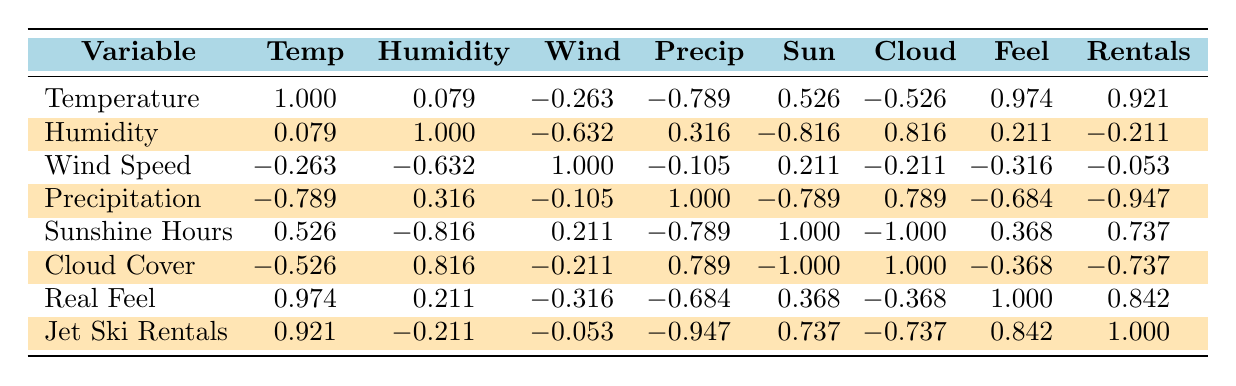What is the correlation between average temperature and jet ski rentals? The correlation value between average temperature and jet ski rentals is 0.921, which indicates a strong positive correlation. This suggests that as the average temperature increases, the demand for jet ski rentals also tends to increase.
Answer: 0.921 Did humidity levels have a negative correlation with jet ski rentals? The correlation value for humidity and jet ski rentals is -0.211, which indicates a weak negative correlation. This means that higher humidity levels are slightly associated with lower rental demand, but the correlation is not strong enough to conclude a significant impact.
Answer: Yes Which weather condition has the strongest negative impact on jet ski rentals? The correlation between precipitation and jet ski rentals is -0.947, which is the strongest negative correlation found in the table. This implies that increased precipitation is significantly associated with decreased demand for jet ski rentals.
Answer: Precipitation What is the average correlation of cloud cover percentage with jet ski rentals? The correlation between cloud cover and jet ski rentals is -0.737. This indicates a substantial negative correlation. Therefore, increased cloud cover generally correlates with lower rental demand.
Answer: -0.737 If the sunshine hours increase by 1 hour, how would it be expected to impact jet ski rentals? The correlation between sunshine hours and jet ski rentals is 0.737, suggesting that an increase in sunshine hours is associated with an increase in jet ski rentals. If sunshine hours increase by 1 hour, we can expect rental demand to rise, considering the strong positive correlation.
Answer: Expected to increase rentals How does the real feel temperature relate to rental demand? The correlation value between real feel temperature and jet ski rentals is 0.842, indicating a strong positive correlation. This means as real feel temperatures rise, the demand for rentals also tends to increase significantly.
Answer: 0.842 What is the overall relationship between wind speed and jet ski rentals? The correlation between wind speed and jet ski rentals is -0.053, which indicates a negligible negative correlation. This suggests that wind speed does not have a significant impact on the demand for jet ski rentals.
Answer: Negligible impact On days with higher humidity, what trend can be expected for jet ski rentals? The correlation between humidity and jet ski rentals is -0.211, which indicates a weak negative correlation. This suggests that on days with higher humidity, there is a tendency for jet ski rentals to decrease slightly, but it's not strong enough to be conclusive.
Answer: Slight decrease in rentals 